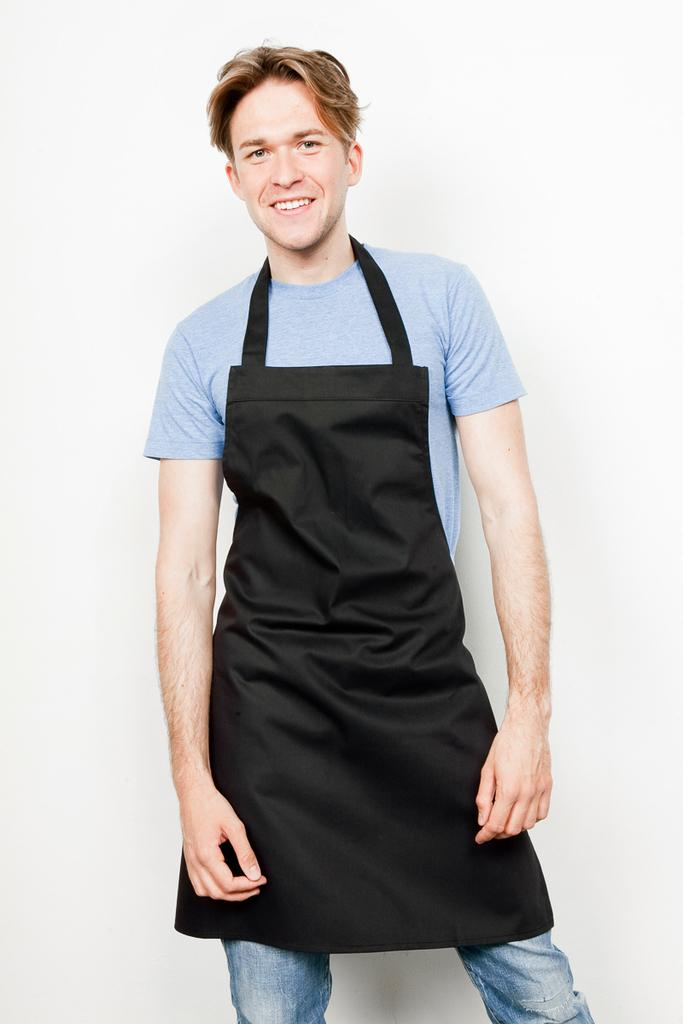Who is present in the image? There is a man in the image. What is the man wearing? The man is wearing an apron. What is the man doing in the image? The man is standing and smiling. What color can be seen in the background of the image? There is a white color visible in the background of the image. What attraction is the boy visiting in the image? There is no boy present in the image, and no attraction is mentioned or visible. 